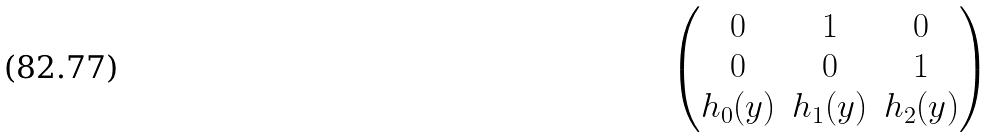<formula> <loc_0><loc_0><loc_500><loc_500>\begin{pmatrix} 0 & 1 & 0 \\ 0 & 0 & 1 \\ h _ { 0 } ( y ) & h _ { 1 } ( y ) & h _ { 2 } ( y ) \end{pmatrix}</formula> 